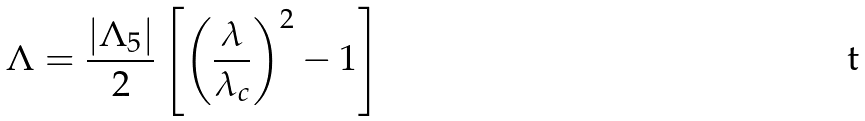<formula> <loc_0><loc_0><loc_500><loc_500>\Lambda = \frac { | \Lambda _ { 5 } | } { 2 } \left [ \left ( \frac { \lambda } { \lambda _ { c } } \right ) ^ { 2 } - 1 \right ]</formula> 